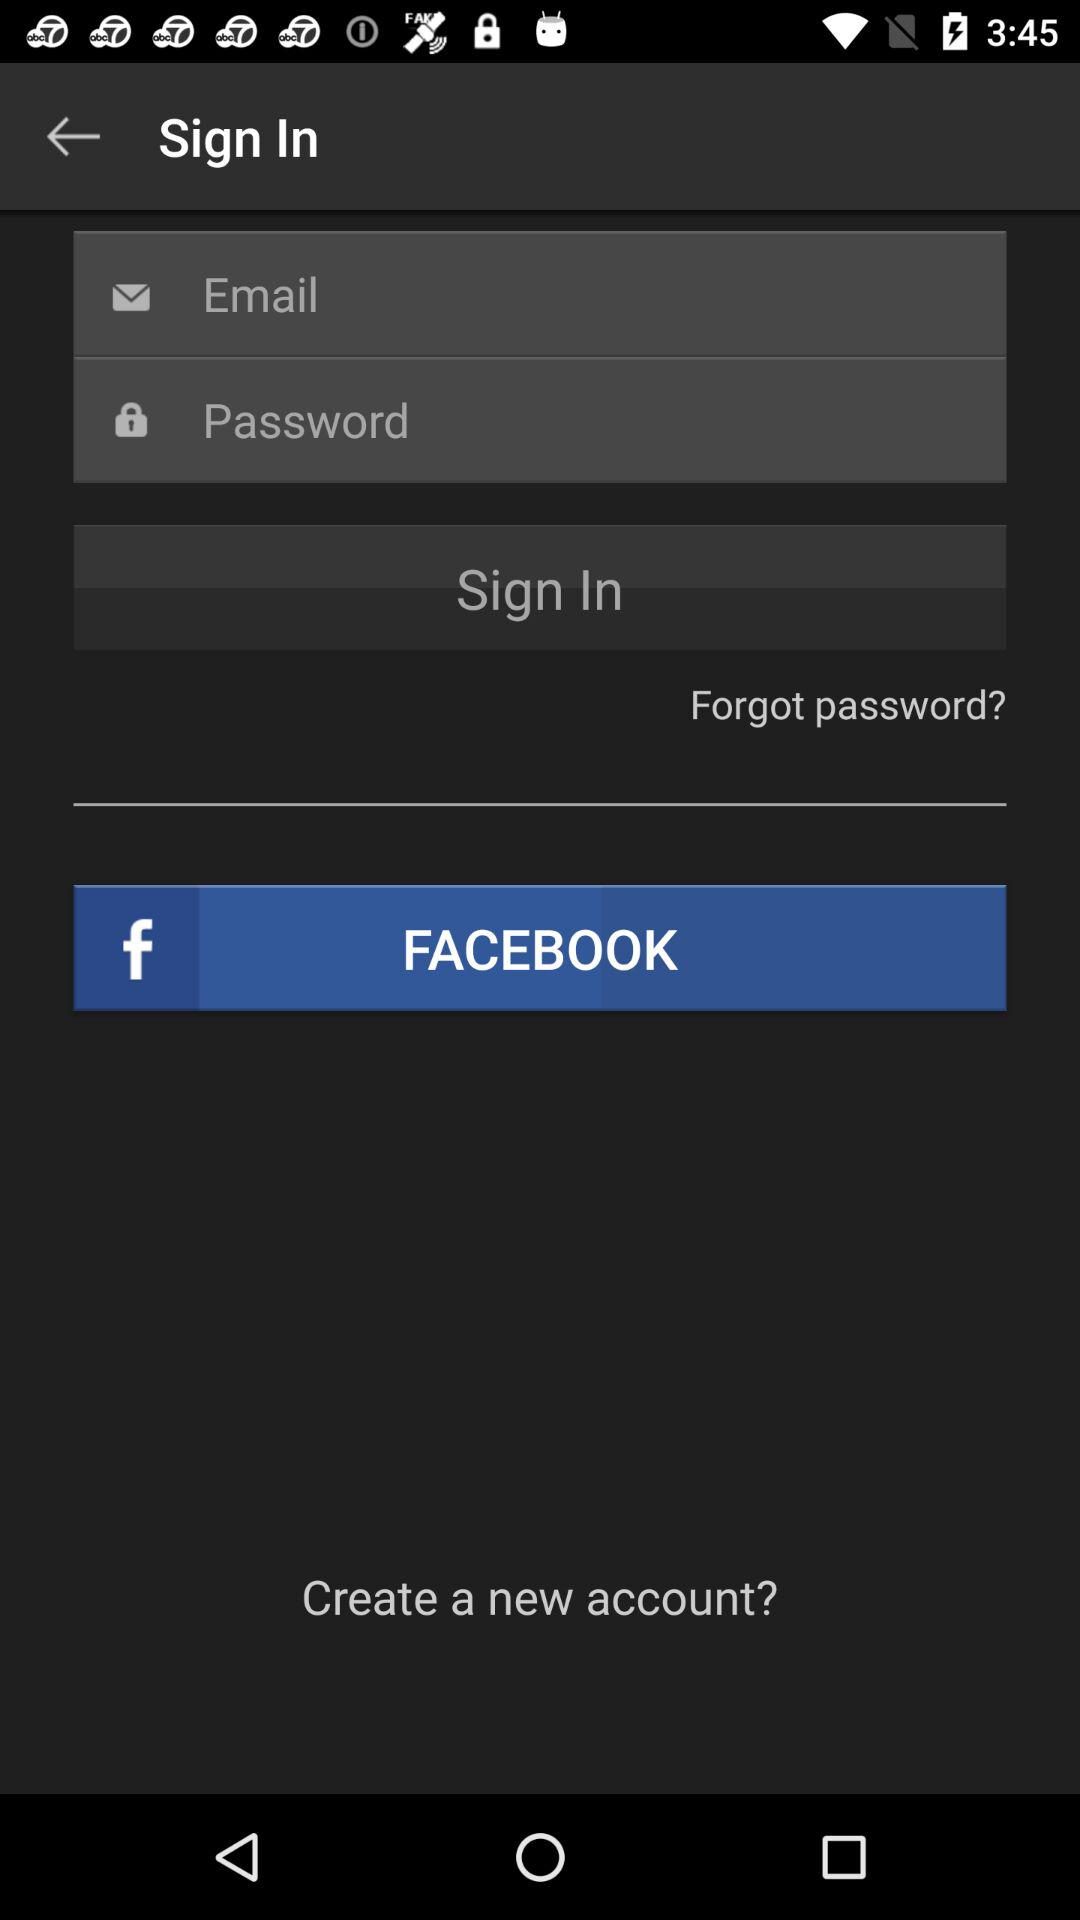What are the requirements for logging in? The requirements are "Email" and "Password". 